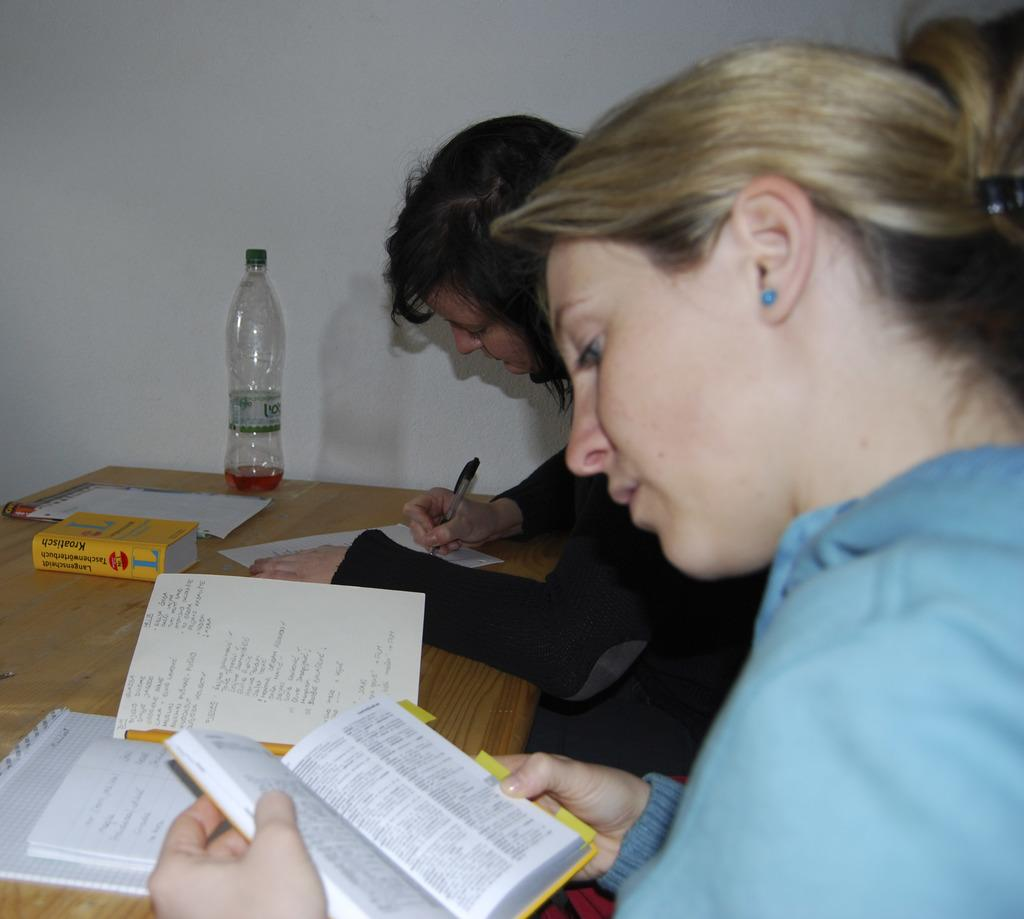<image>
Describe the image concisely. Two women at a desk, working, one has a foreign book with a large L on it in front of her. 